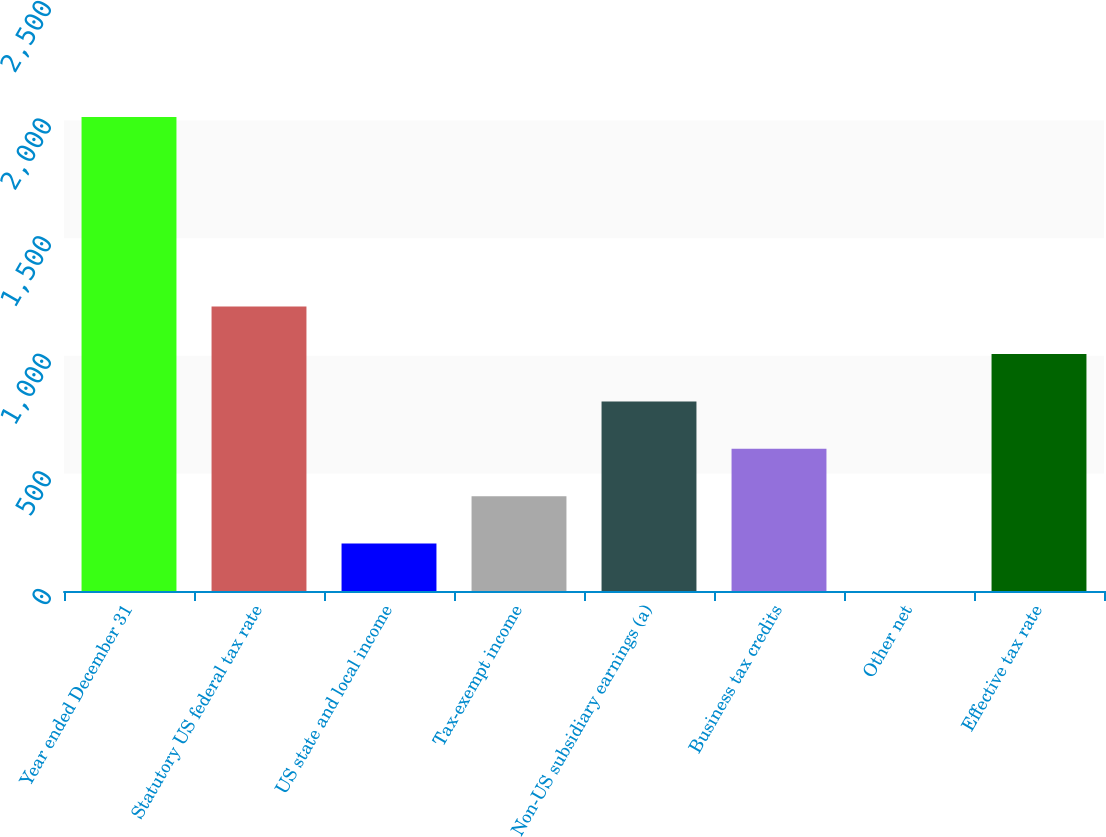<chart> <loc_0><loc_0><loc_500><loc_500><bar_chart><fcel>Year ended December 31<fcel>Statutory US federal tax rate<fcel>US state and local income<fcel>Tax-exempt income<fcel>Non-US subsidiary earnings (a)<fcel>Business tax credits<fcel>Other net<fcel>Effective tax rate<nl><fcel>2015<fcel>1209.12<fcel>201.77<fcel>403.24<fcel>806.18<fcel>604.71<fcel>0.3<fcel>1007.65<nl></chart> 